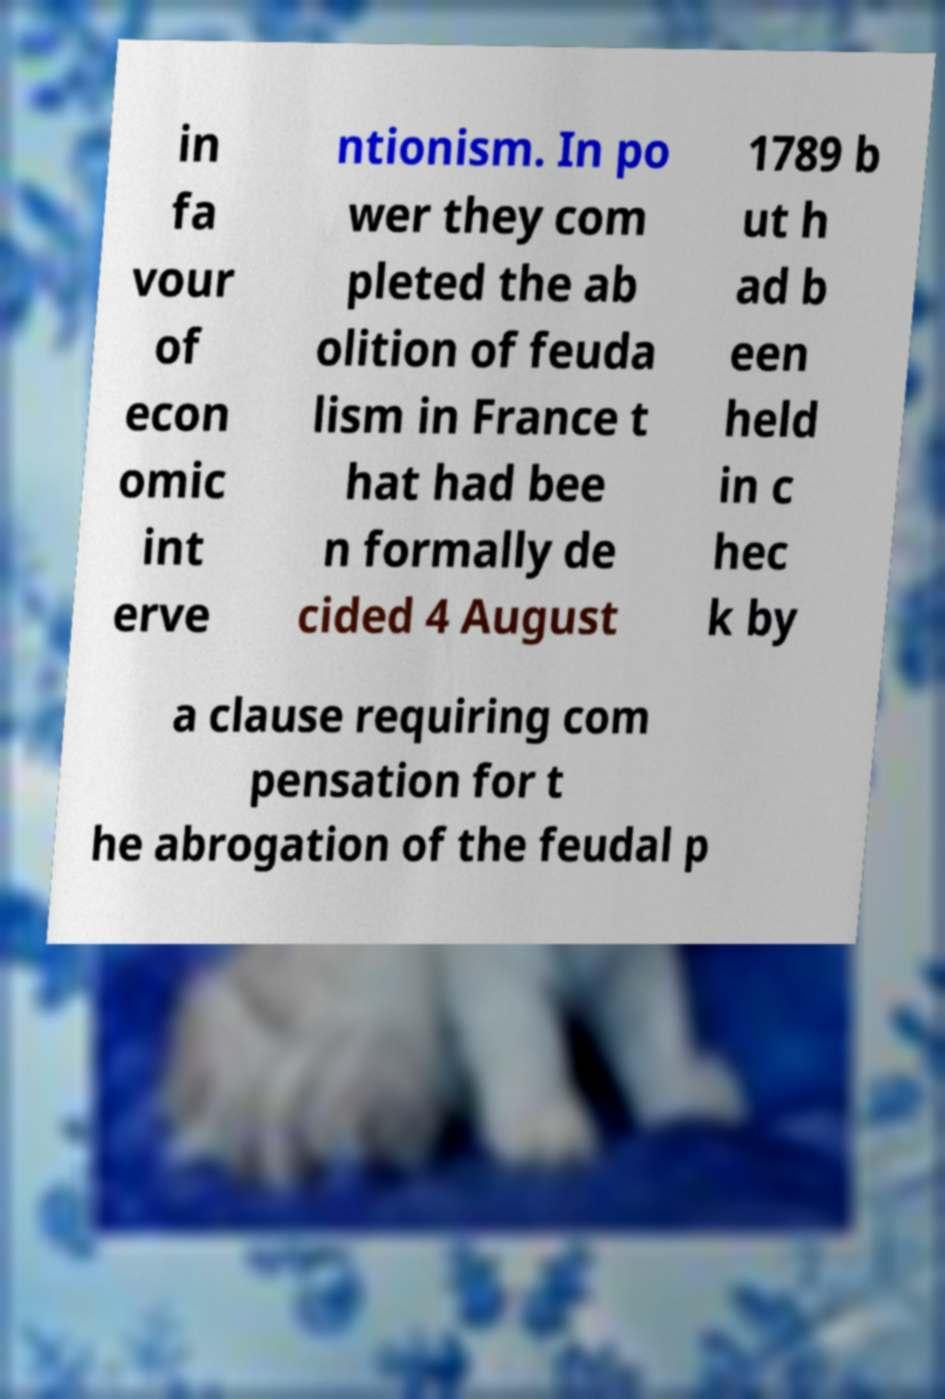Please read and relay the text visible in this image. What does it say? in fa vour of econ omic int erve ntionism. In po wer they com pleted the ab olition of feuda lism in France t hat had bee n formally de cided 4 August 1789 b ut h ad b een held in c hec k by a clause requiring com pensation for t he abrogation of the feudal p 